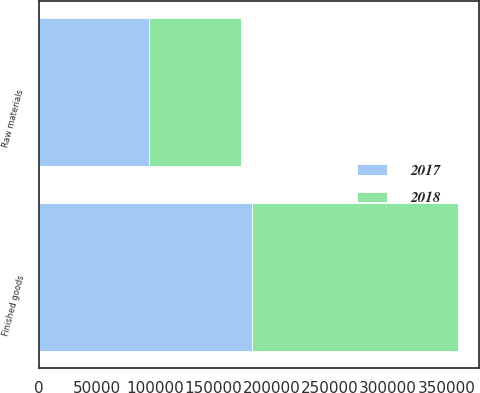Convert chart to OTSL. <chart><loc_0><loc_0><loc_500><loc_500><stacked_bar_chart><ecel><fcel>Raw materials<fcel>Finished goods<nl><fcel>2017<fcel>94421<fcel>183284<nl><fcel>2018<fcel>78834<fcel>176911<nl></chart> 